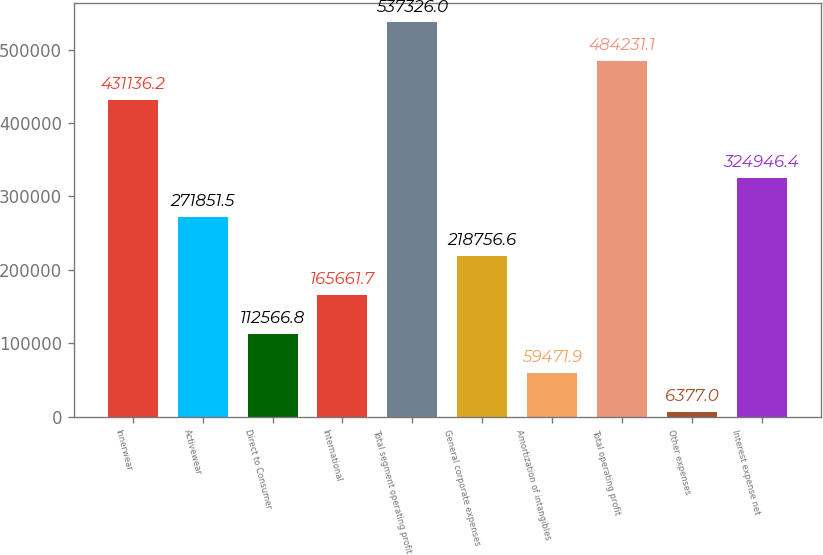Convert chart to OTSL. <chart><loc_0><loc_0><loc_500><loc_500><bar_chart><fcel>Innerwear<fcel>Activewear<fcel>Direct to Consumer<fcel>International<fcel>Total segment operating profit<fcel>General corporate expenses<fcel>Amortization of intangibles<fcel>Total operating profit<fcel>Other expenses<fcel>Interest expense net<nl><fcel>431136<fcel>271852<fcel>112567<fcel>165662<fcel>537326<fcel>218757<fcel>59471.9<fcel>484231<fcel>6377<fcel>324946<nl></chart> 